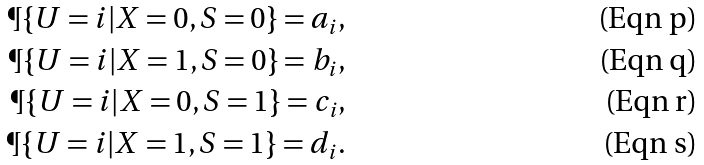<formula> <loc_0><loc_0><loc_500><loc_500>\P \{ U = i | X = 0 , S = 0 \} = a _ { i } , \\ \P \{ U = i | X = 1 , S = 0 \} = b _ { i } , \\ \P \{ U = i | X = 0 , S = 1 \} = c _ { i } , \\ \P \{ U = i | X = 1 , S = 1 \} = d _ { i } .</formula> 